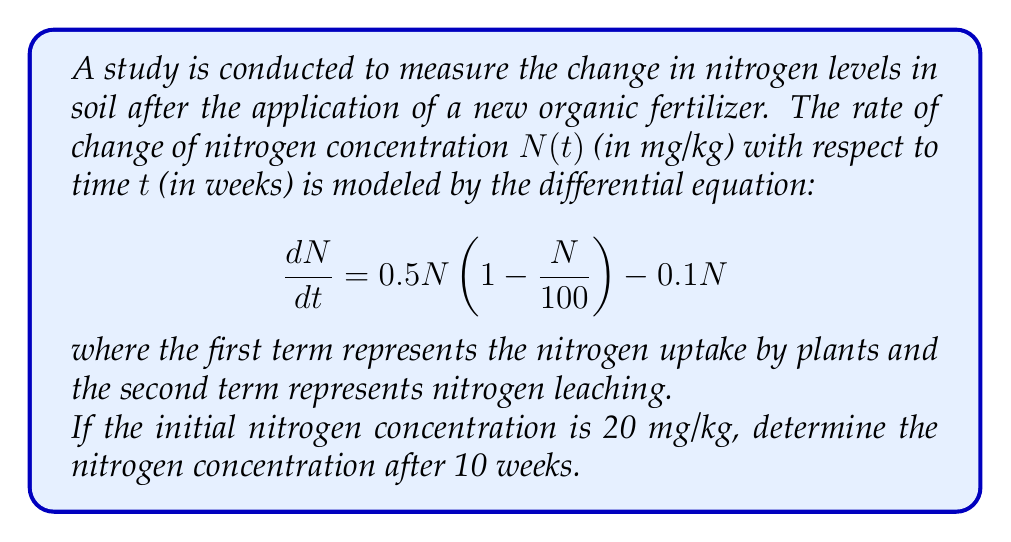Help me with this question. To solve this problem, we need to follow these steps:

1) First, let's rearrange the differential equation:

   $$\frac{dN}{dt} = 0.5N(1 - \frac{N}{100}) - 0.1N = 0.5N - 0.005N^2 - 0.1N = 0.4N - 0.005N^2$$

2) This is a separable differential equation. We can rewrite it as:

   $$\frac{dN}{0.4N - 0.005N^2} = dt$$

3) Integrate both sides:

   $$\int \frac{dN}{0.4N - 0.005N^2} = \int dt$$

4) The left side can be integrated using partial fractions:

   $$\int \frac{dN}{N(0.4 - 0.005N)} = \int \frac{1}{80} (\frac{1}{N} + \frac{1}{80-N}) dN = \frac{1}{80} [\ln|N| - \ln|80-N|] + C = t + C$$

5) Simplify:

   $$\ln|\frac{N}{80-N}| = 80t + C$$

6) Apply the initial condition: $N(0) = 20$

   $$\ln|\frac{20}{60}| = C$$

   $$C = \ln|\frac{1}{3}|$$

7) Substitute back:

   $$\ln|\frac{N}{80-N}| = 80t + \ln|\frac{1}{3}|$$

8) Simplify:

   $$\frac{N}{80-N} = \frac{1}{3}e^{80t}$$

9) Solve for N:

   $$N = \frac{80e^{80t}}{3 + e^{80t}}$$

10) Now, we can find N(10) by substituting t = 10:

    $$N(10) = \frac{80e^{800}}{3 + e^{800}} \approx 79.999 \text{ mg/kg}$$
Answer: The nitrogen concentration after 10 weeks is approximately 79.999 mg/kg. 